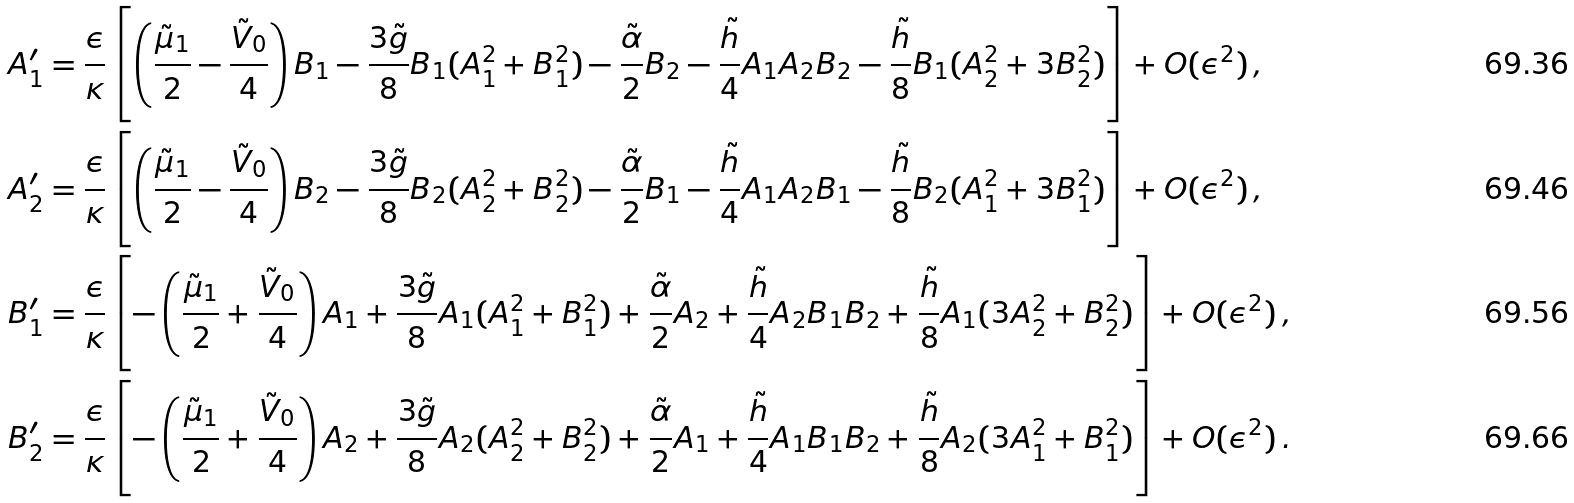Convert formula to latex. <formula><loc_0><loc_0><loc_500><loc_500>A _ { 1 } ^ { \prime } & = \frac { \epsilon } { \kappa } \left [ \left ( \frac { \tilde { \mu } _ { 1 } } { 2 } - \frac { \tilde { V } _ { 0 } } { 4 } \right ) B _ { 1 } - \frac { 3 \tilde { g } } { 8 } B _ { 1 } ( A _ { 1 } ^ { 2 } + B _ { 1 } ^ { 2 } ) - \frac { \tilde { \alpha } } { 2 } B _ { 2 } - \frac { \tilde { h } } { 4 } A _ { 1 } A _ { 2 } B _ { 2 } - \frac { \tilde { h } } { 8 } B _ { 1 } ( A _ { 2 } ^ { 2 } + 3 B _ { 2 } ^ { 2 } ) \right ] + O ( \epsilon ^ { 2 } ) \, , \\ A _ { 2 } ^ { \prime } & = \frac { \epsilon } { \kappa } \left [ \left ( \frac { \tilde { \mu } _ { 1 } } { 2 } - \frac { \tilde { V } _ { 0 } } { 4 } \right ) B _ { 2 } - \frac { 3 \tilde { g } } { 8 } B _ { 2 } ( A _ { 2 } ^ { 2 } + B _ { 2 } ^ { 2 } ) - \frac { \tilde { \alpha } } { 2 } B _ { 1 } - \frac { \tilde { h } } { 4 } A _ { 1 } A _ { 2 } B _ { 1 } - \frac { \tilde { h } } { 8 } B _ { 2 } ( A _ { 1 } ^ { 2 } + 3 B _ { 1 } ^ { 2 } ) \right ] + O ( \epsilon ^ { 2 } ) \, , \\ B _ { 1 } ^ { \prime } & = \frac { \epsilon } { \kappa } \left [ - \left ( \frac { \tilde { \mu } _ { 1 } } { 2 } + \frac { \tilde { V } _ { 0 } } { 4 } \right ) A _ { 1 } + \frac { 3 \tilde { g } } { 8 } A _ { 1 } ( A _ { 1 } ^ { 2 } + B _ { 1 } ^ { 2 } ) + \frac { \tilde { \alpha } } { 2 } A _ { 2 } + \frac { \tilde { h } } { 4 } A _ { 2 } B _ { 1 } B _ { 2 } + \frac { \tilde { h } } { 8 } A _ { 1 } ( 3 A _ { 2 } ^ { 2 } + B _ { 2 } ^ { 2 } ) \right ] + O ( \epsilon ^ { 2 } ) \, , \\ B _ { 2 } ^ { \prime } & = \frac { \epsilon } { \kappa } \left [ - \left ( \frac { \tilde { \mu } _ { 1 } } { 2 } + \frac { \tilde { V } _ { 0 } } { 4 } \right ) A _ { 2 } + \frac { 3 \tilde { g } } { 8 } A _ { 2 } ( A _ { 2 } ^ { 2 } + B _ { 2 } ^ { 2 } ) + \frac { \tilde { \alpha } } { 2 } A _ { 1 } + \frac { \tilde { h } } { 4 } A _ { 1 } B _ { 1 } B _ { 2 } + \frac { \tilde { h } } { 8 } A _ { 2 } ( 3 A _ { 1 } ^ { 2 } + B _ { 1 } ^ { 2 } ) \right ] + O ( \epsilon ^ { 2 } ) \, .</formula> 